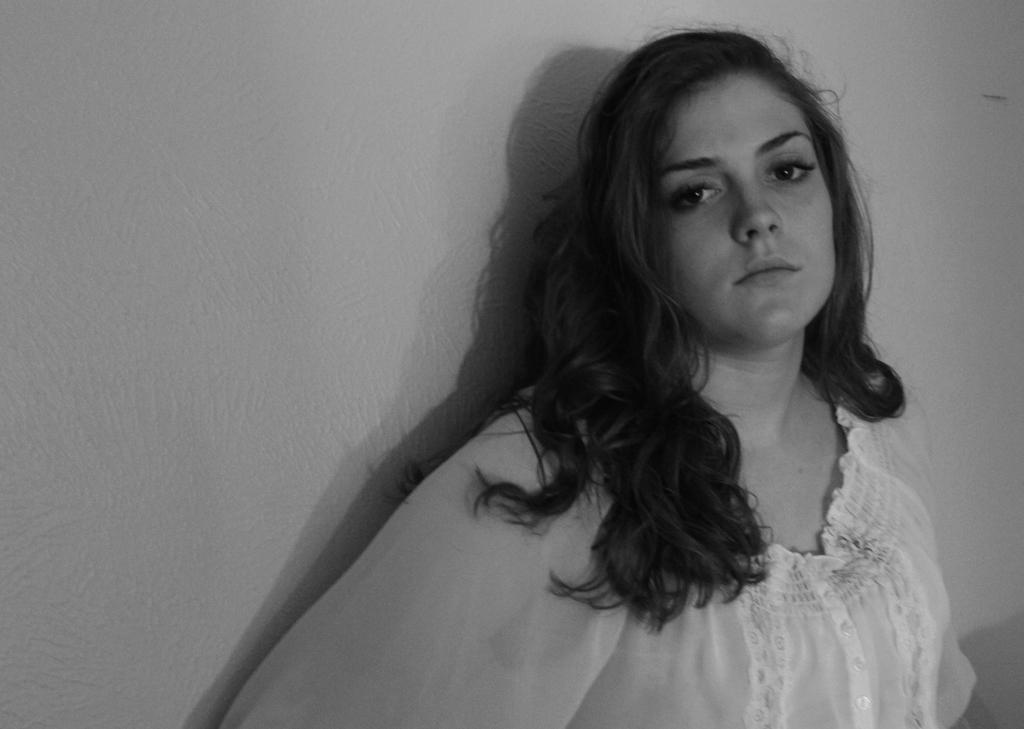What is the color scheme of the image? The image is black and white. What can be seen in the background of the image? There is a wall in the background of the image. Who is the main subject in the image? There is a woman in the middle of the image. What type of bubbles can be seen floating around the woman in the image? There are no bubbles present in the image; it is a black and white image with a woman in the middle. 